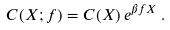Convert formula to latex. <formula><loc_0><loc_0><loc_500><loc_500>C ( X ; f ) = C ( X ) \, e ^ { \beta f X } \, .</formula> 